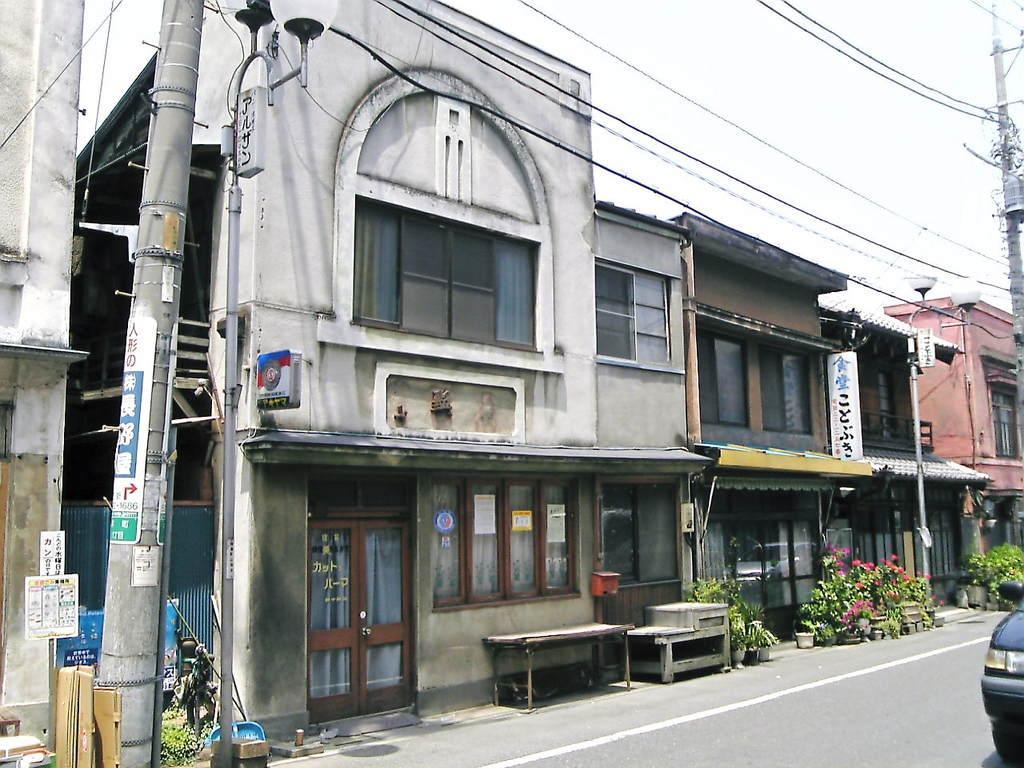Can you describe this image briefly? In the image we can see there are buildings and these are the windows of the buildings. We can even see a vehicle on the road. There is a road and white lines on the road. We can even see there are electric poles and light poles and these are the electric wires. Here we can see flower plant pots, door and a white sky. 